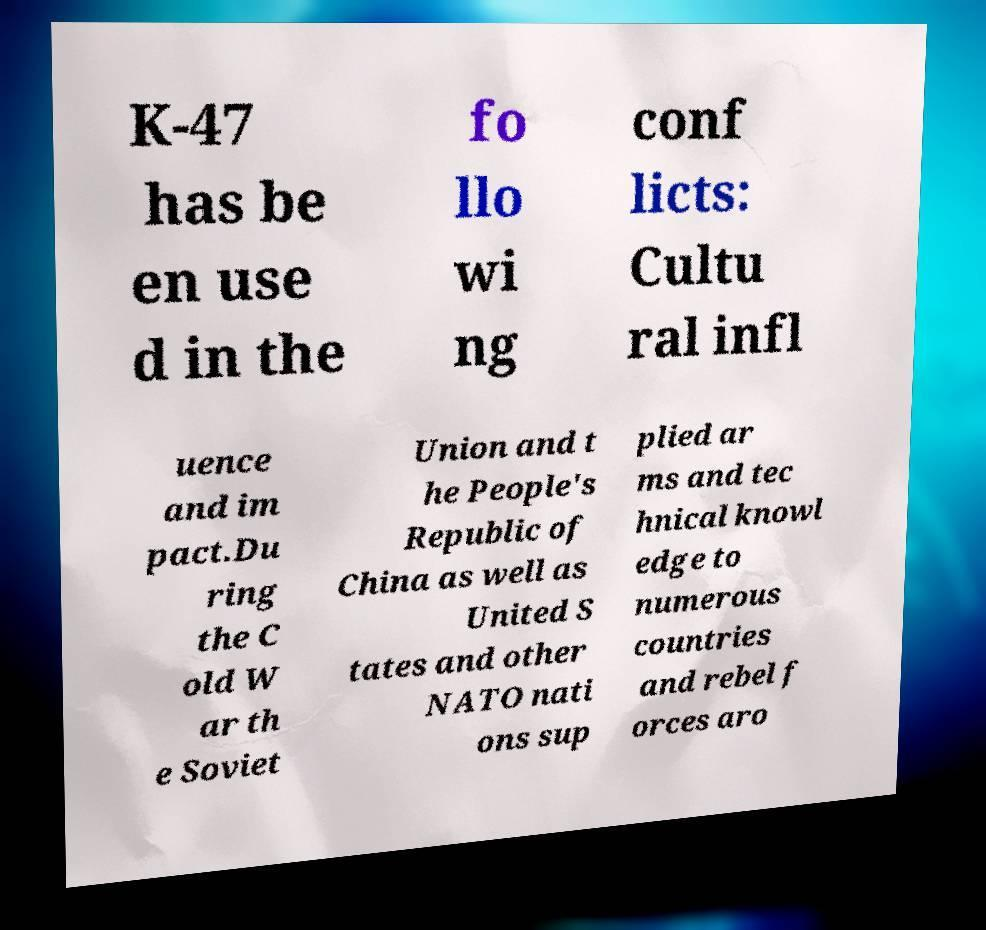Could you assist in decoding the text presented in this image and type it out clearly? K-47 has be en use d in the fo llo wi ng conf licts: Cultu ral infl uence and im pact.Du ring the C old W ar th e Soviet Union and t he People's Republic of China as well as United S tates and other NATO nati ons sup plied ar ms and tec hnical knowl edge to numerous countries and rebel f orces aro 